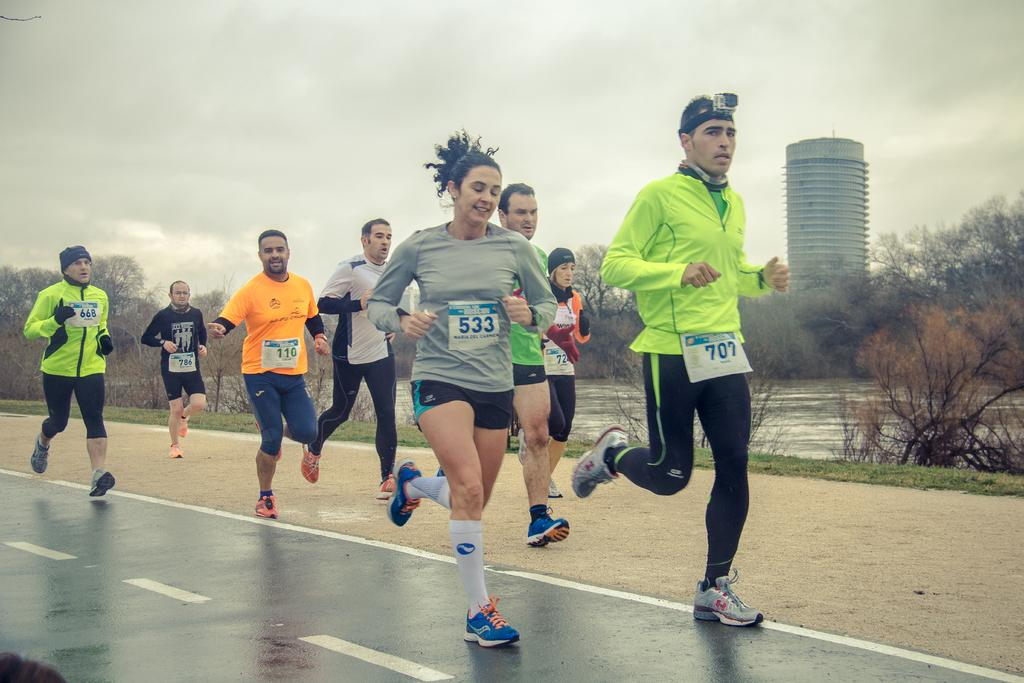How many people are in the image? There is a group of people in the image. What are the people in the image doing? The people are running on the road. What can be seen in the background of the image? There are trees, water, grass, a building, and the sky visible in the background of the image. What type of planes can be seen flying in the image? There are no planes visible in the image; it only shows a group of people running on the road and the background elements. 